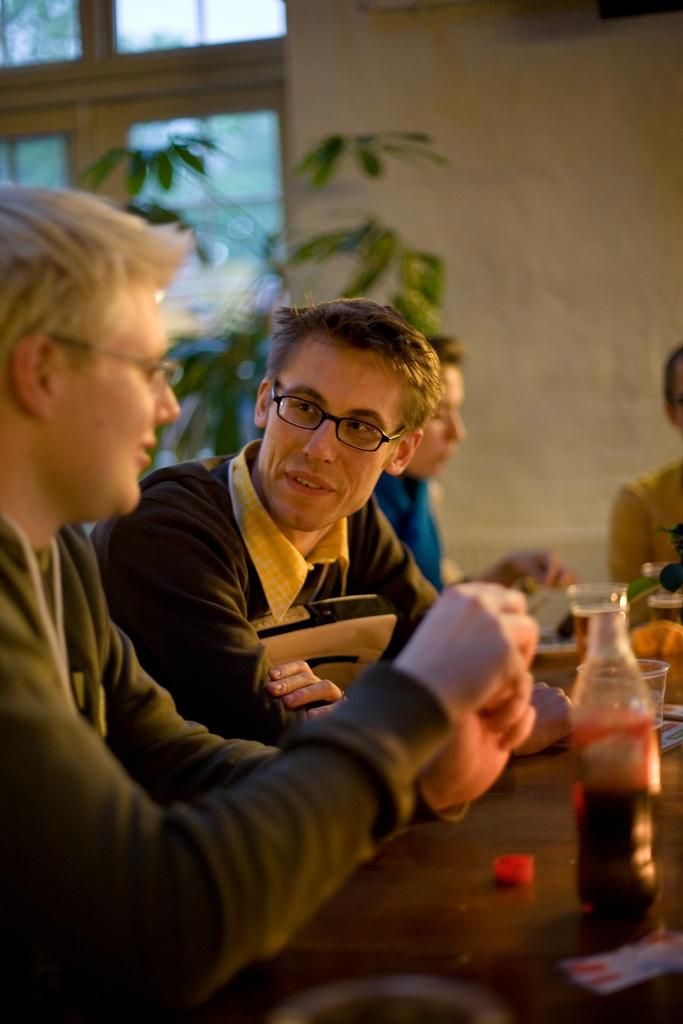How many persons are in the image? There are persons in the image. What are the persons wearing? The persons are wearing spectacles. What is on the table in the image? There is a bottle and glasses on the table. What can be seen in the background of the image? There is a wall and a plant in the background of the image. What type of bulb is illuminating the persons in the image? There is no bulb present in the image; the persons are not being illuminated by a light source. What form does the plant in the background of the image take? The plant in the background of the image is not described in detail, so it is not possible to determine its form. 